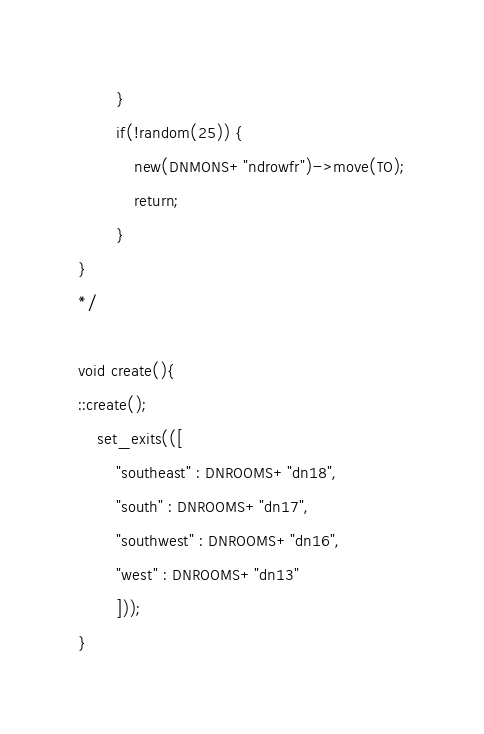<code> <loc_0><loc_0><loc_500><loc_500><_C_>        }
        if(!random(25)) {
            new(DNMONS+"ndrowfr")->move(TO);
            return;
        }
}
*/

void create(){
::create();
  	set_exits(([
		"southeast" : DNROOMS+"dn18",
		"south" : DNROOMS+"dn17",
		"southwest" : DNROOMS+"dn16",
		"west" : DNROOMS+"dn13"
    	]));
}</code> 